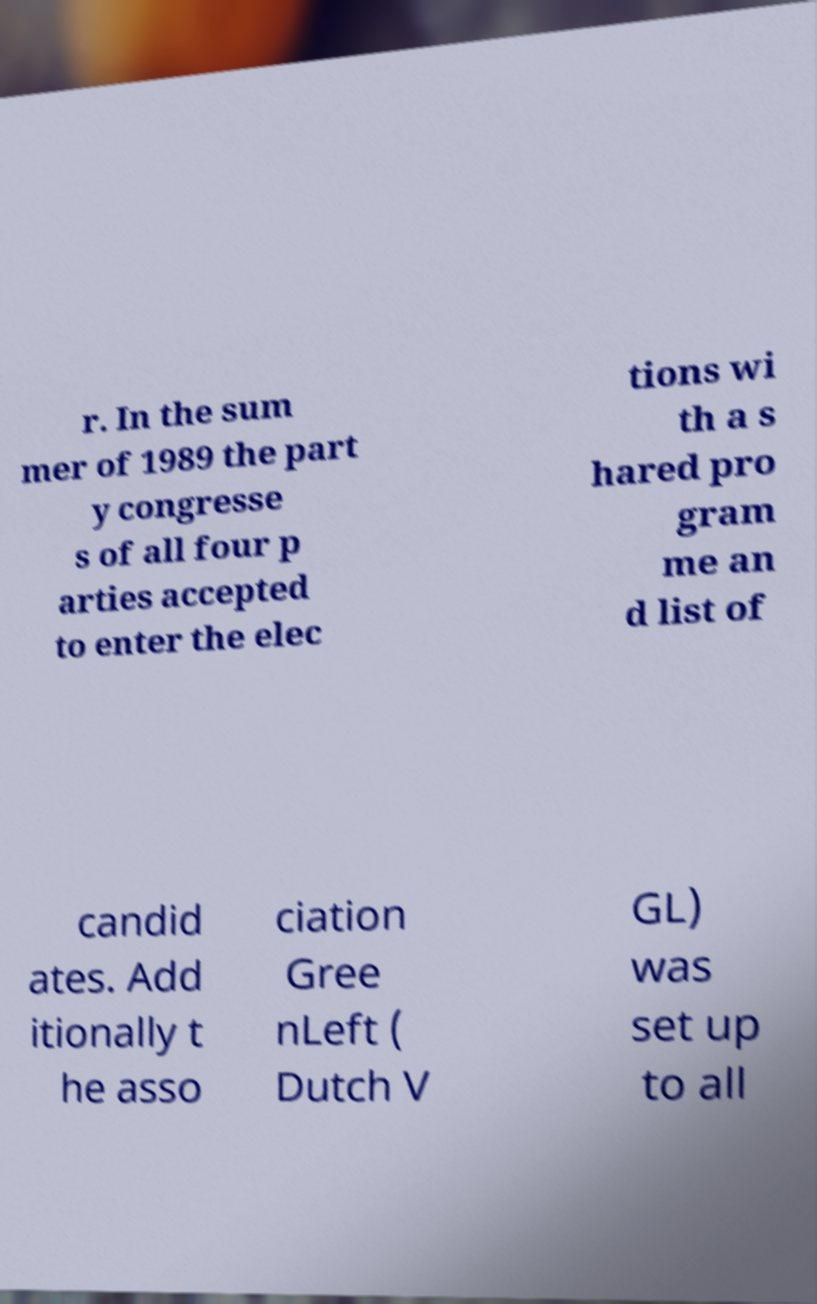Can you accurately transcribe the text from the provided image for me? r. In the sum mer of 1989 the part y congresse s of all four p arties accepted to enter the elec tions wi th a s hared pro gram me an d list of candid ates. Add itionally t he asso ciation Gree nLeft ( Dutch V GL) was set up to all 